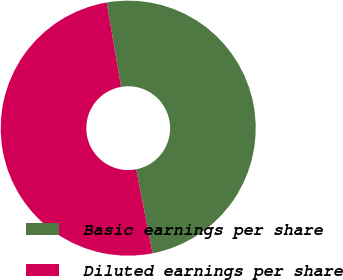<chart> <loc_0><loc_0><loc_500><loc_500><pie_chart><fcel>Basic earnings per share<fcel>Diluted earnings per share<nl><fcel>49.64%<fcel>50.36%<nl></chart> 